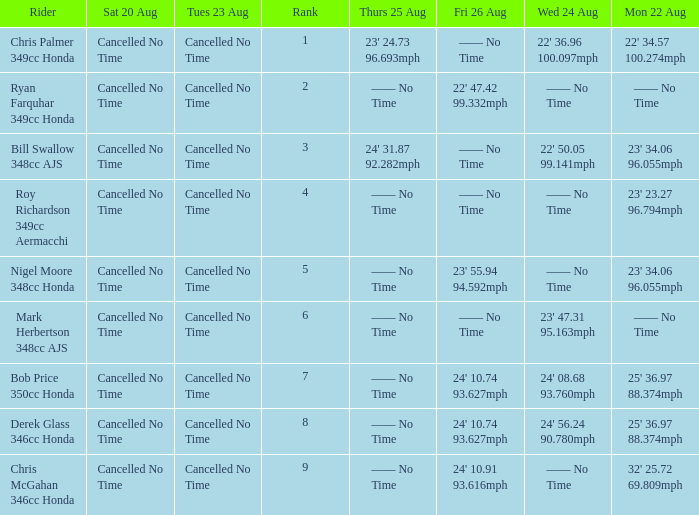What is every entry on Monday August 22 when the entry for Wednesday August 24 is 22' 50.05 99.141mph? 23' 34.06 96.055mph. 